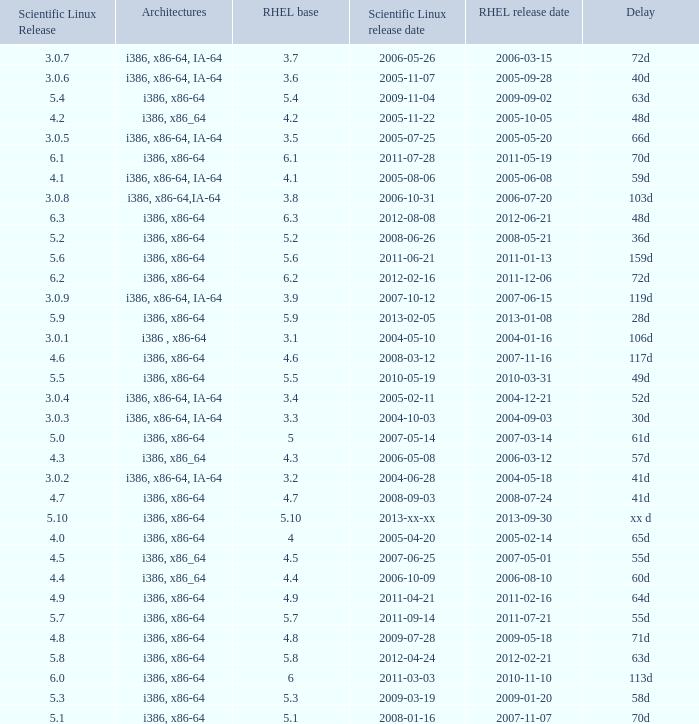Name the scientific linux release when delay is 28d 5.9. 